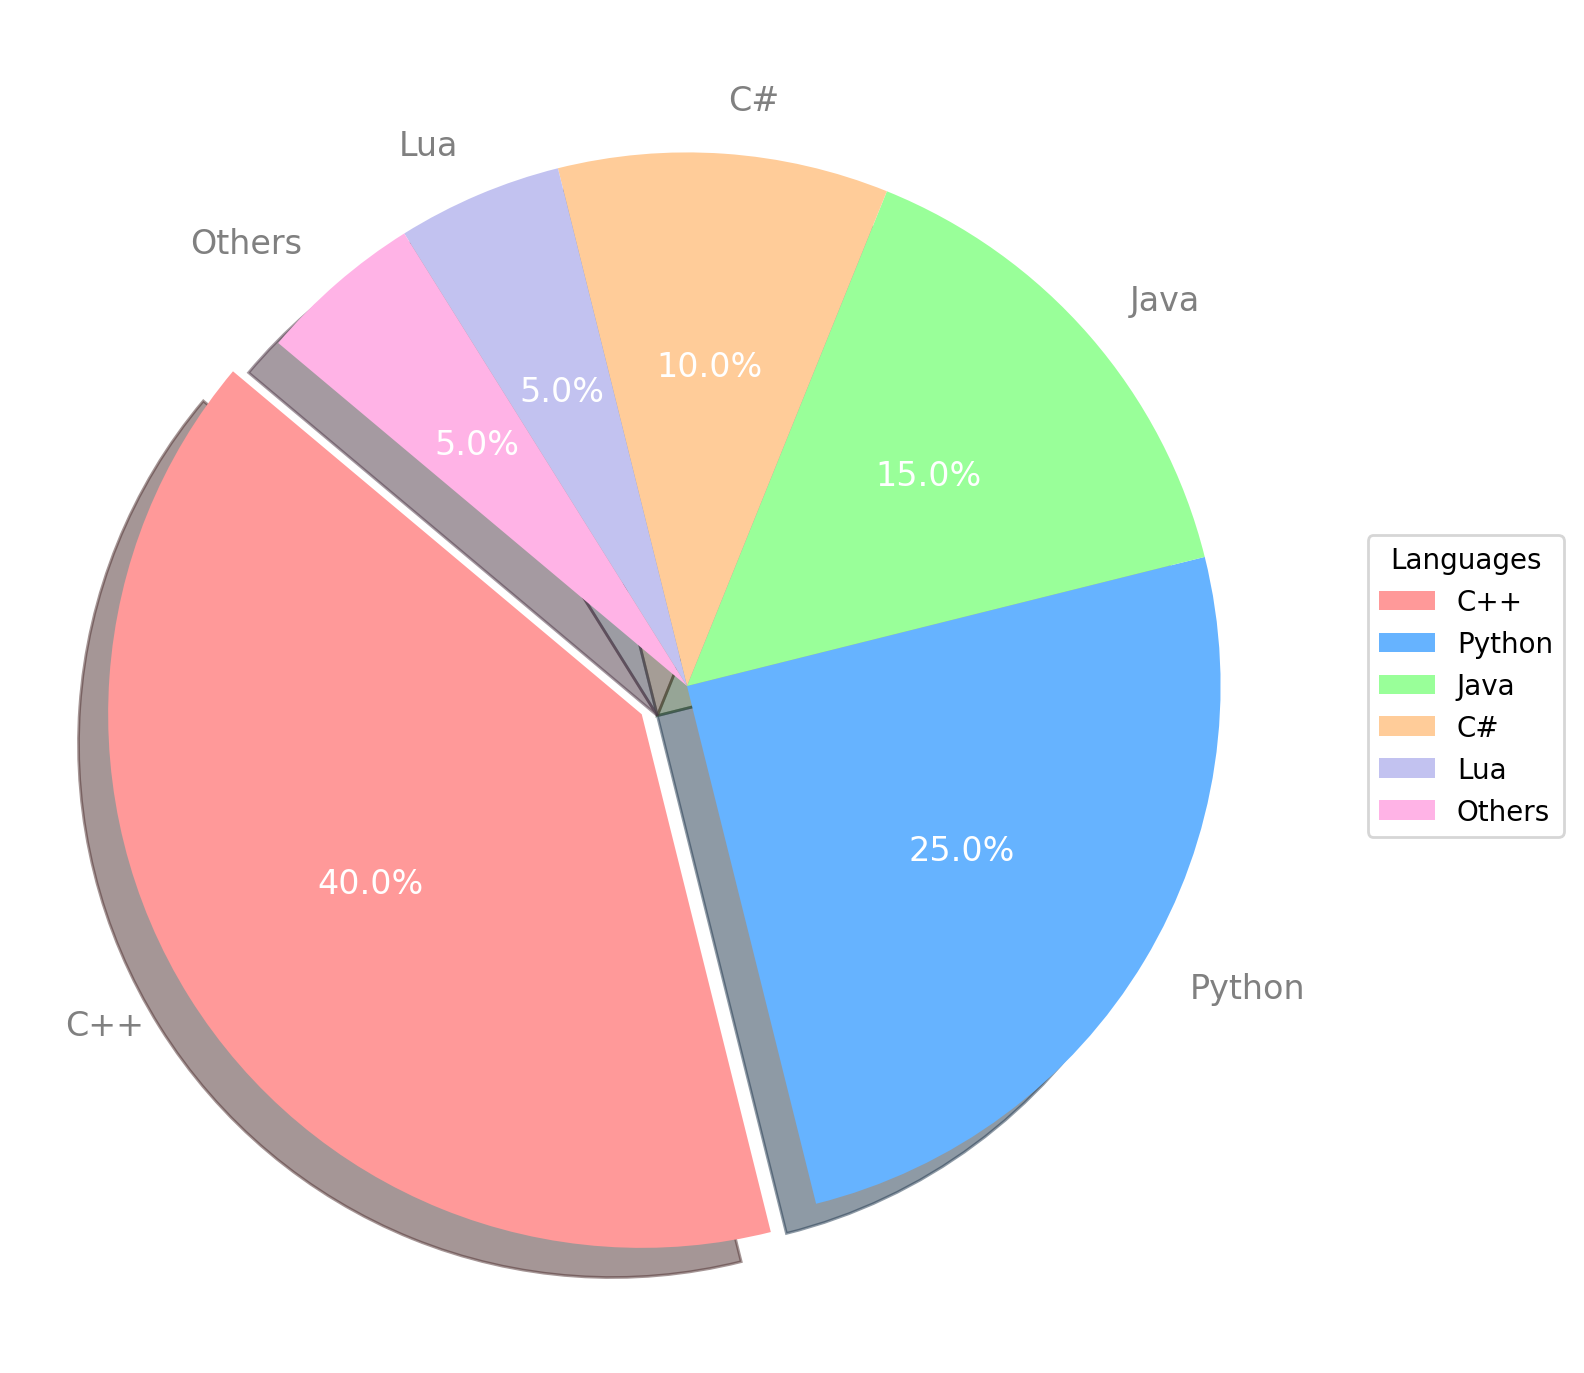what percentage of usage is attributed to C++? The percentage of usage for C++ is directly shown on the pie chart. You can identify it by looking for the largest slice, which is exploded, labeled "C++". The label will show the percentage value.
Answer: 40% if we combine the usage of Python and Java, how much would it be? To find the combined usage percentage of Python and Java, add their individual percentages. Python is 25% and Java is 15%, so 25 + 15 = 40%
Answer: 40% which language has the smallest usage percentage and what is it? Identify the smallest slice in the pie chart and check its label. The smallest slice is labeled "Lua" with a usage percentage of 5%.
Answer: Lua, 5% what is the difference in usage percentage between C++ and C#? Subtract the usage percentage of C# from that of C++. C++ has 40% and C# has 10%, so 40 - 10 = 30%
Answer: 30% how many languages have a usage percentage higher than 10%? Count the number of slices with a label indicating a percentage higher than 10%. C++, Python, and Java all have percentages over 10%. Thus, there are three such languages.
Answer: 3 what color is the slice representing Python? Look for the slice labeled "Python" and note its color. Python is represented by a slice colored in blue.
Answer: blue how much more is the usage percentage of C++ compared to the combined percentage of Lua and Others? Lua and Others each have 5%, so combined they make 5 + 5 = 10%. The usage percentage of C++ is 40%. Subtract the combined percentage from C++, 40 - 10 = 30%.
Answer: 30% which slice of the pie chart is exploded, and what does it represent? The exploded slice is visually separated from the rest of the pie chart. It represents the programming language C++.
Answer: C++ if we need to calculate the average usage percentage of all languages shown, what will be the value? Add all the percentage values and divide by the number of languages. The total sum is 40 + 25 + 15 + 10 + 5 + 5 = 100. There are 6 languages, so 100 / 6 = 16.67%
Answer: 16.67% compare the usage percentages of Java and C#. which one has the higher percentage and by how much? Java and C# slices show 15% and 10%, respectively. Java has a higher percentage. Subtract C#'s percentage from Java's, 15 - 10 = 5%.
Answer: Java, 5% 